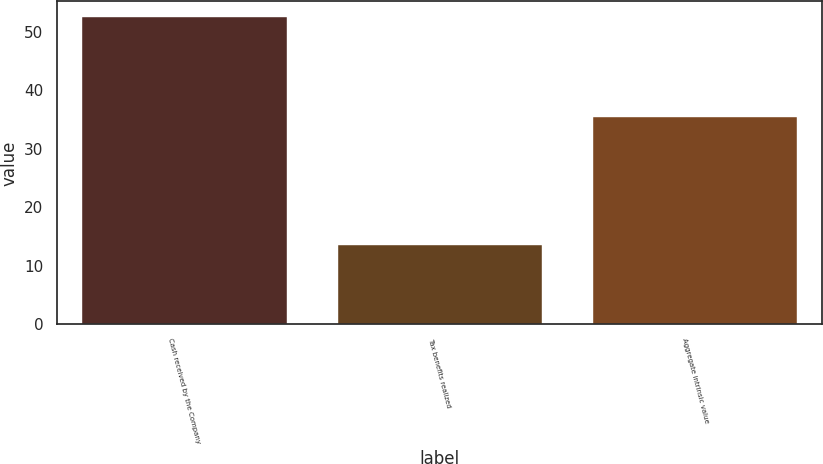Convert chart to OTSL. <chart><loc_0><loc_0><loc_500><loc_500><bar_chart><fcel>Cash received by the Company<fcel>Tax benefits realized<fcel>Aggregate intrinsic value<nl><fcel>52.6<fcel>13.6<fcel>35.5<nl></chart> 